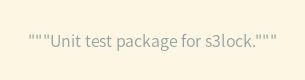<code> <loc_0><loc_0><loc_500><loc_500><_Python_>"""Unit test package for s3lock."""
</code> 